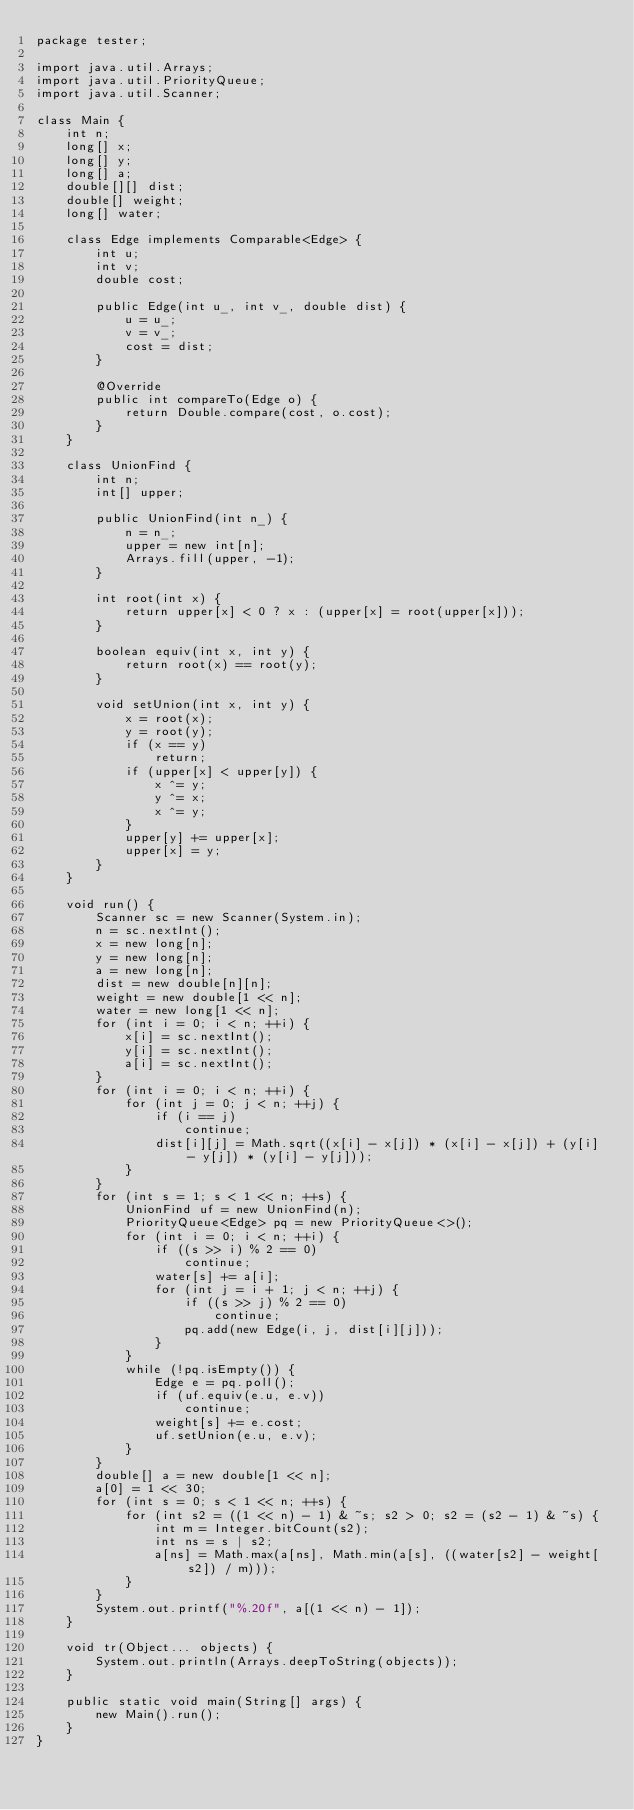Convert code to text. <code><loc_0><loc_0><loc_500><loc_500><_Java_>package tester;

import java.util.Arrays;
import java.util.PriorityQueue;
import java.util.Scanner;

class Main {
	int n;
	long[] x;
	long[] y;
	long[] a;
	double[][] dist;
	double[] weight;
	long[] water;

	class Edge implements Comparable<Edge> {
		int u;
		int v;
		double cost;

		public Edge(int u_, int v_, double dist) {
			u = u_;
			v = v_;
			cost = dist;
		}

		@Override
		public int compareTo(Edge o) {
			return Double.compare(cost, o.cost);
		}
	}

	class UnionFind {
		int n;
		int[] upper;

		public UnionFind(int n_) {
			n = n_;
			upper = new int[n];
			Arrays.fill(upper, -1);
		}

		int root(int x) {
			return upper[x] < 0 ? x : (upper[x] = root(upper[x]));
		}

		boolean equiv(int x, int y) {
			return root(x) == root(y);
		}

		void setUnion(int x, int y) {
			x = root(x);
			y = root(y);
			if (x == y)
				return;
			if (upper[x] < upper[y]) {
				x ^= y;
				y ^= x;
				x ^= y;
			}
			upper[y] += upper[x];
			upper[x] = y;
		}
	}

	void run() {
		Scanner sc = new Scanner(System.in);
		n = sc.nextInt();
		x = new long[n];
		y = new long[n];
		a = new long[n];
		dist = new double[n][n];
		weight = new double[1 << n];
		water = new long[1 << n];
		for (int i = 0; i < n; ++i) {
			x[i] = sc.nextInt();
			y[i] = sc.nextInt();
			a[i] = sc.nextInt();
		}
		for (int i = 0; i < n; ++i) {
			for (int j = 0; j < n; ++j) {
				if (i == j)
					continue;
				dist[i][j] = Math.sqrt((x[i] - x[j]) * (x[i] - x[j]) + (y[i] - y[j]) * (y[i] - y[j]));
			}
		}
		for (int s = 1; s < 1 << n; ++s) {
			UnionFind uf = new UnionFind(n);
			PriorityQueue<Edge> pq = new PriorityQueue<>();
			for (int i = 0; i < n; ++i) {
				if ((s >> i) % 2 == 0)
					continue;
				water[s] += a[i];
				for (int j = i + 1; j < n; ++j) {
					if ((s >> j) % 2 == 0)
						continue;
					pq.add(new Edge(i, j, dist[i][j]));
				}
			}
			while (!pq.isEmpty()) {
				Edge e = pq.poll();
				if (uf.equiv(e.u, e.v))
					continue;
				weight[s] += e.cost;
				uf.setUnion(e.u, e.v);
			}
		}
		double[] a = new double[1 << n];
		a[0] = 1 << 30;
		for (int s = 0; s < 1 << n; ++s) {
			for (int s2 = ((1 << n) - 1) & ~s; s2 > 0; s2 = (s2 - 1) & ~s) {
				int m = Integer.bitCount(s2);
				int ns = s | s2;
				a[ns] = Math.max(a[ns], Math.min(a[s], ((water[s2] - weight[s2]) / m)));
			}
		}
		System.out.printf("%.20f", a[(1 << n) - 1]);
	}

	void tr(Object... objects) {
		System.out.println(Arrays.deepToString(objects));
	}

	public static void main(String[] args) {
		new Main().run();
	}
}</code> 